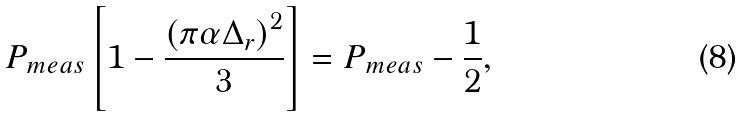<formula> <loc_0><loc_0><loc_500><loc_500>P _ { m e a s } \left [ 1 - \frac { \left ( \pi \alpha \Delta _ { r } \right ) ^ { 2 } } { 3 } \right ] = P _ { m e a s } - \frac { 1 } { 2 } ,</formula> 